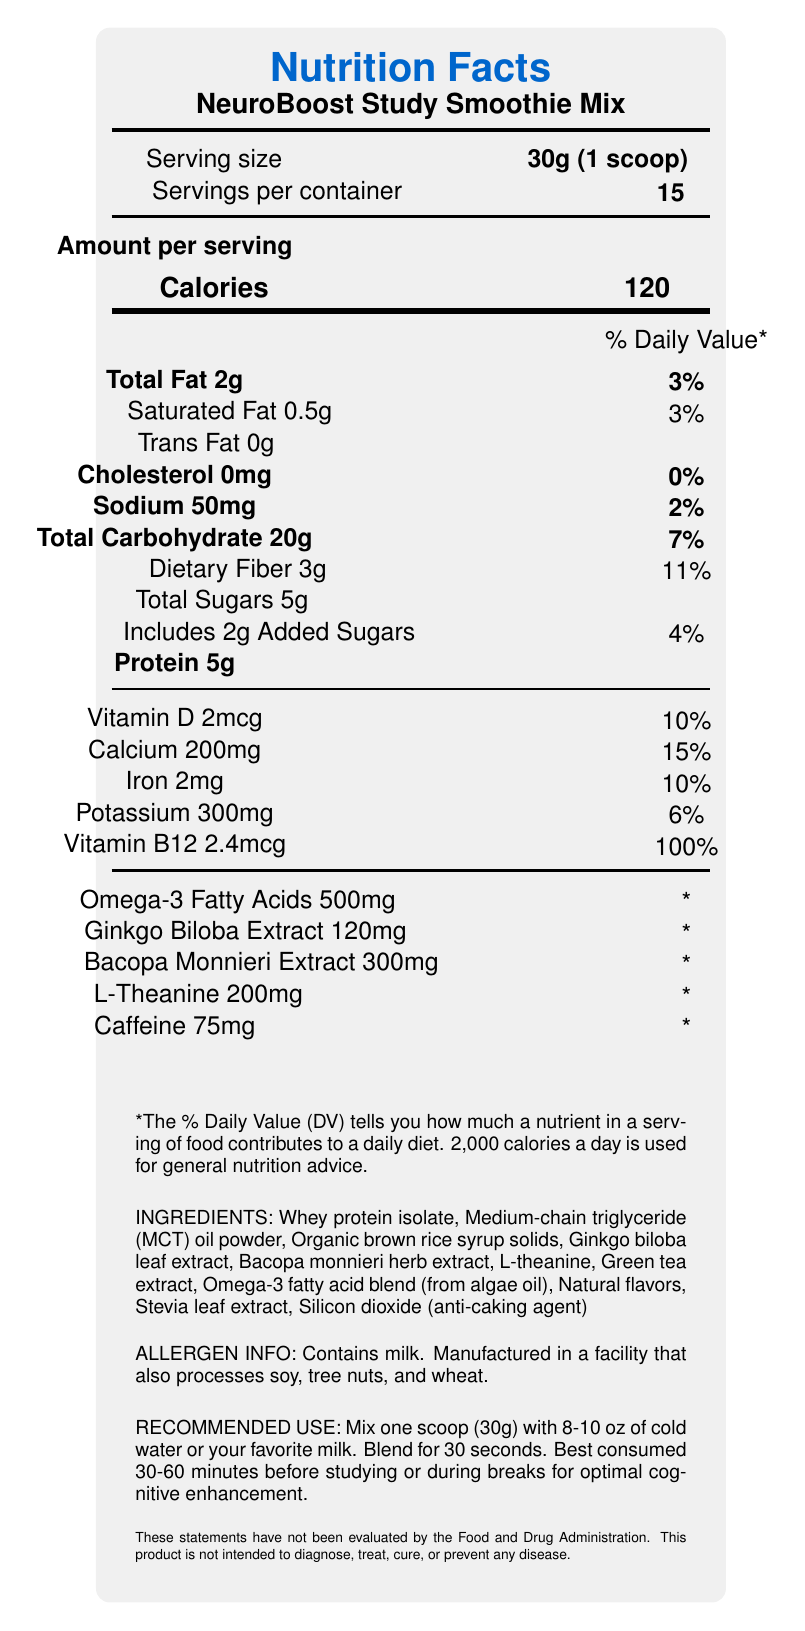What is the serving size for the NeuroBoost Study Smoothie Mix? The serving size is explicitly listed as "30g (1 scoop)" in the document.
Answer: 30g (1 scoop) How many calories are in one serving? The document states "Calories 120" under the "Amount per serving" section.
Answer: 120 calories What percentage of daily value does the Total Fat provide? The document shows "Total Fat 2g" and its corresponding daily value as "3%" in the % Daily Value column.
Answer: 3% What are the primary ingredients used in the NeuroBoost Study Smoothie Mix? The ingredients are listed towards the bottom of the document under "INGREDIENTS."
Answer: Whey protein isolate, Medium-chain triglyceride (MCT) oil powder, Organic brown rice syrup solids, Ginkgo biloba leaf extract, Bacopa monnieri herb extract, L-theanine, Green tea extract, Omega-3 fatty acid blend (from algae oil), Natural flavors, Stevia leaf extract, Silicon dioxide (anti-caking agent) Does the product contain caffeine? The document lists "Caffeine 75mg" under its nutrient information.
Answer: Yes What is the percentage daily value of Dietary Fiber in one serving? The document shows "Dietary Fiber 3g" with a corresponding daily value of "11%."
Answer: 11% What is the amount of Vitamin B12 provided per serving according to the document? The document specifies "Vitamin B12 2.4mcg."
Answer: 2.4mcg Which of the following ingredients is included in the NeuroBoost Study Smoothie Mix?
A. Soy lecithin
B. Green tea extract
C. Corn syrup The ingredients list includes "Green tea extract" but does not list "Soy lecithin" or "Corn syrup."
Answer: B. Green tea extract How many servings are there in a container of NeuroBoost Study Smoothie Mix?
1. 10
2. 12
3. 15
4. 20 The document mentions "Servings per container: 15."
Answer: 3. 15 What is the recommended use for this product? The document clearly states the recommended use under "RECOMMENDED USE."
Answer: Mix one scoop (30g) with 8-10 oz of cold water or your favorite milk. Blend for 30 seconds. Best consumed 30-60 minutes before studying or during breaks for optimal cognitive enhancement. Is this product evaluated by the Food and Drug Administration? The disclaimer at the bottom of the document states "These statements have not been evaluated by the Food and Drug Administration."
Answer: No What are the intended benefits of using the NeuroBoost Study Smoothie Mix? These benefits are listed under the "engineered benefits" section in the document.
Answer: Improved focus and concentration, Enhanced memory retention, Increased mental clarity, Sustainable energy without jitters, Support for long-term cognitive health Summarize the main idea of the document. The document contains comprehensive nutrition facts, ingredients, usage instructions, and cognitive benefits for the NeuroBoost Study Smoothie Mix, aimed at supporting enhanced cognitive performance during study sessions.
Answer: The NeuroBoost Study Smoothie Mix is a dietary supplement designed to enhance cognitive function during intense study sessions. The nutrition facts label provides details about the serving size, calories, macronutrients, vitamins, and special ingredients like caffeine and nootropics. Additionally, the document includes ingredients, allergen information, recommended use, storage instructions, disclaimers, and intended cognitive benefits. Does the product contain any tree nuts? While the allergen info states that the product is manufactured in a facility that processes tree nuts, it does not mention if the product itself contains tree nuts. Therefore, this detail cannot be determined from the given information alone.
Answer: Cannot be determined 